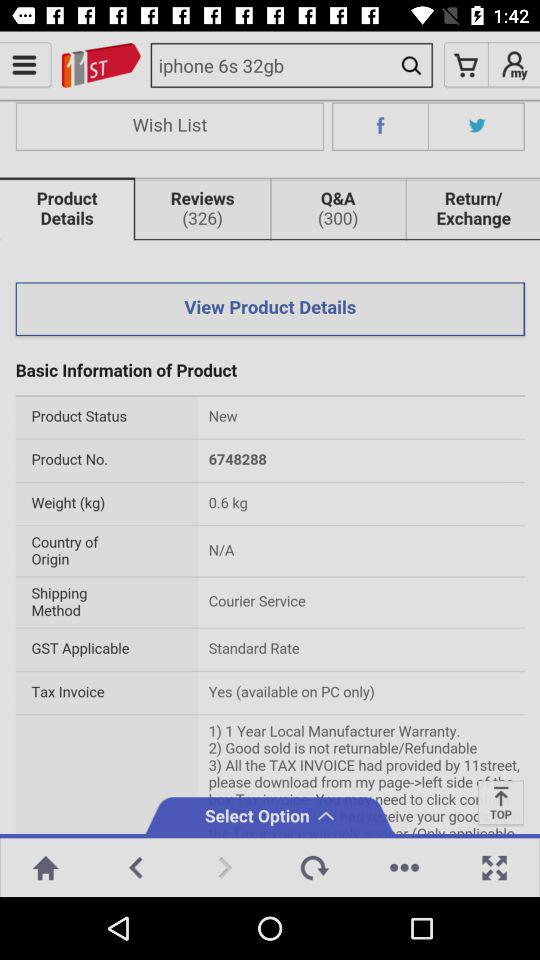What is the total discount of the two coupons?
Answer the question using a single word or phrase. 33% 